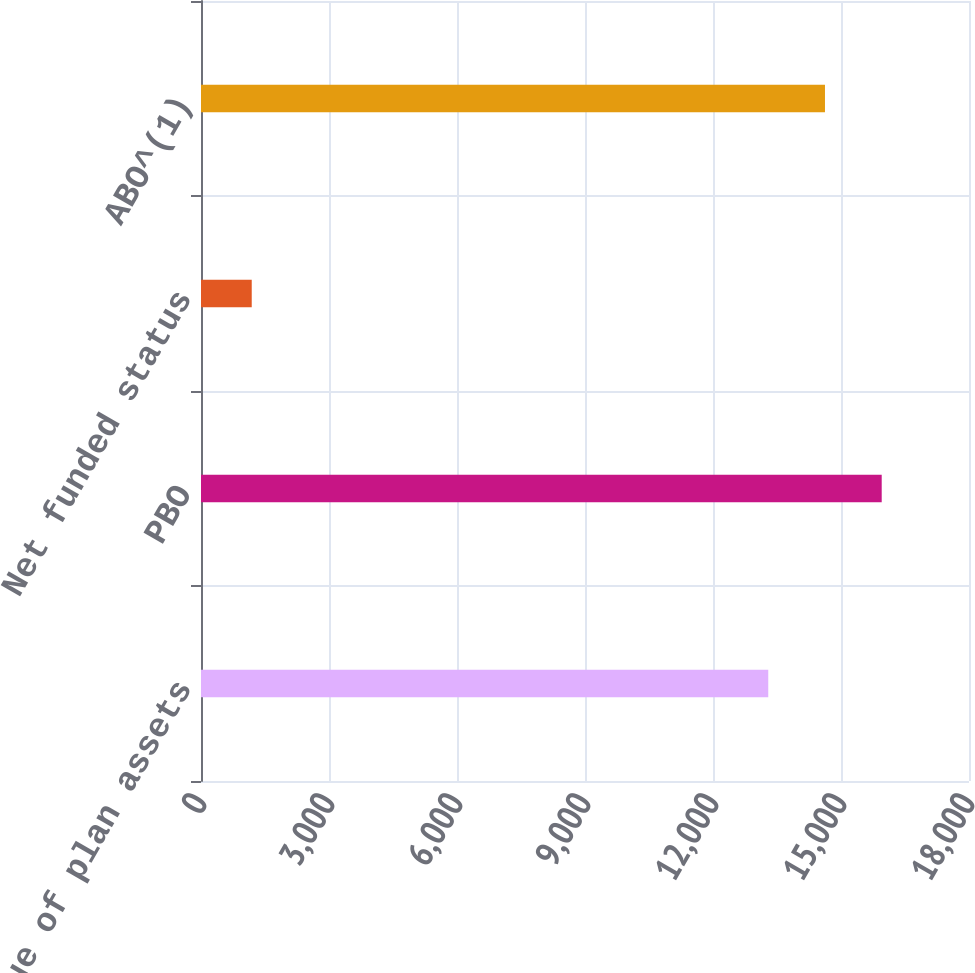Convert chart to OTSL. <chart><loc_0><loc_0><loc_500><loc_500><bar_chart><fcel>Fair value of plan assets<fcel>PBO<fcel>Net funded status<fcel>ABO^(1)<nl><fcel>13295<fcel>15954<fcel>1189<fcel>14624.5<nl></chart> 